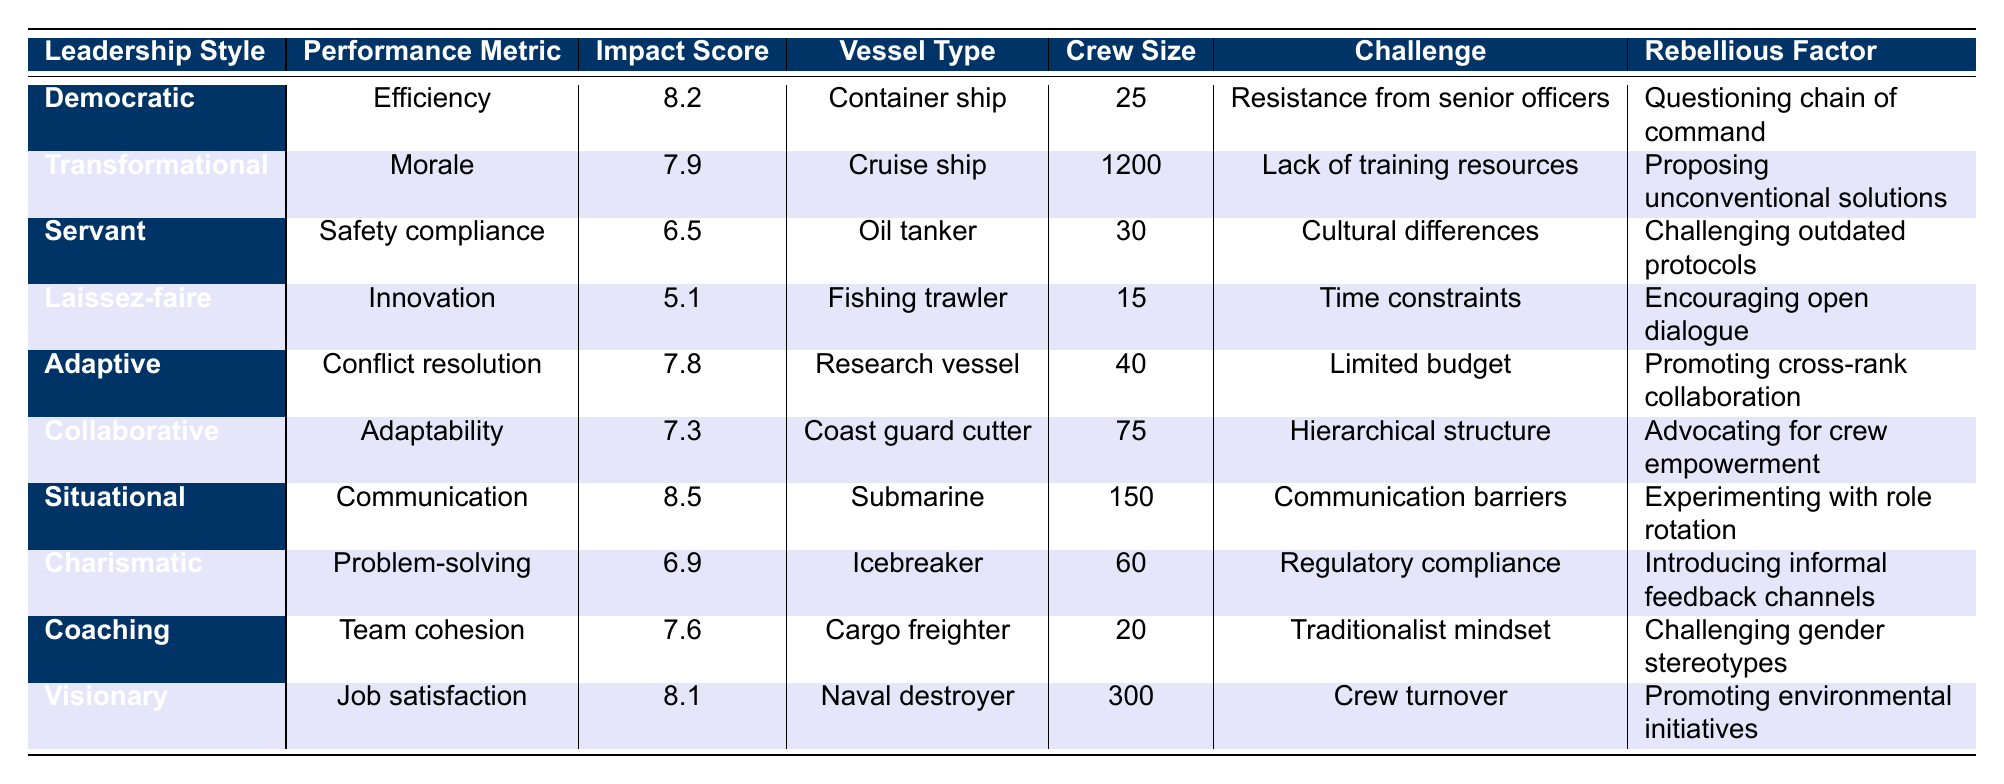What is the impact score for the Situational leadership style? The impact score is specifically listed in the table for the Situational leadership style in the respective row, which shows it as 8.5.
Answer: 8.5 Which leadership style has the highest impact score? By looking at the impact scores listed, the highest score is 8.5, associated with the Situational leadership style.
Answer: Situational How many crew members are typically on a Cruise ship? The table indicates that a Cruise ship typically has a crew size of 1200, which is explicitly listed next to the corresponding vessel type.
Answer: 1200 What is the impact score of Servant leadership style and what performance metric does it relate to? The impact score of the Servant leadership style is 6.5, and it relates to the performance metric of Safety compliance as shown in the table.
Answer: 6.5, Safety compliance Which leadership style corresponds to the implementation challenge of "Hierarchical structure"? In the table, the Collaborative leadership style is associated with the implementation challenge of Hierarchical structure, as indicated in its row.
Answer: Collaborative Calculate the average impact score of leadership styles associated with small crew sizes (fewer than 30 crew members). The relevant styles with small crew sizes (15 for Laissez-faire and 20 for Coaching) have scores of 5.1 and 7.6, respectively. Their average is (5.1 + 7.6) / 2 = 6.35.
Answer: 6.35 Is the impact score of the Charismatic leadership style higher than that of the Servant leadership style? The impact score for Charismatic is 6.9, which is lower than the Servant leadership style's score of 6.5. Therefore, it is false that Charismatic is higher.
Answer: No Which vessel type has the lowest impact score and what is that score? The Laissez-faire leadership style, associated with the Fishing trawler as its vessel type, has the lowest impact score of 5.1 as listed in the table.
Answer: Fishing trawler, 5.1 How does the impact score of Adaptive leadership compare to that of Collaborative leadership? The Adaptive leadership style has an impact score of 7.8, which is higher than the Collaborative leadership style's score of 7.3. Therefore, Adaptive is greater than Collaborative in impact.
Answer: Adaptive is higher What percentage of crew metrics show an impact score above 7? There are 6 out of 10 leadership styles with scores over 7. Thus, the percentage is (6 / 10) * 100 = 60%.
Answer: 60% 